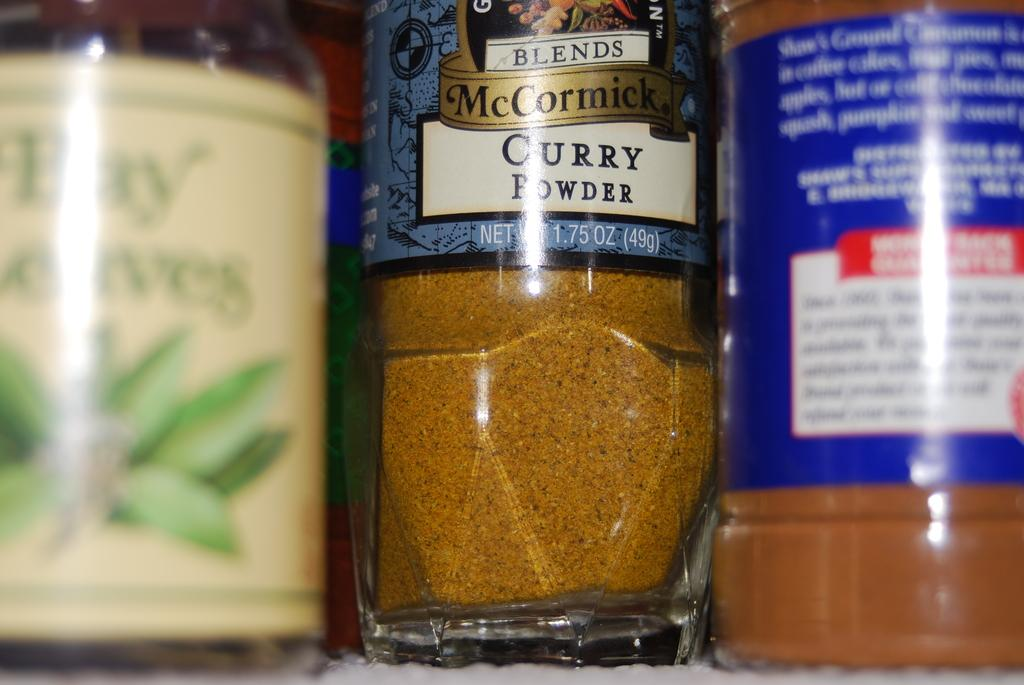How many bottles are visible in the image? There are three bottles in the image. What is inside one of the bottles? One of the bottles contains curry powder. What colors are present on the labels of the other two bottles? The labels on the other two bottles have colors blue, white, and green. Are there any pets visible in the image? No, there are no pets present in the image. Can you see a receipt for the purchase of the bottles in the image? No, there is no receipt visible in the image. 